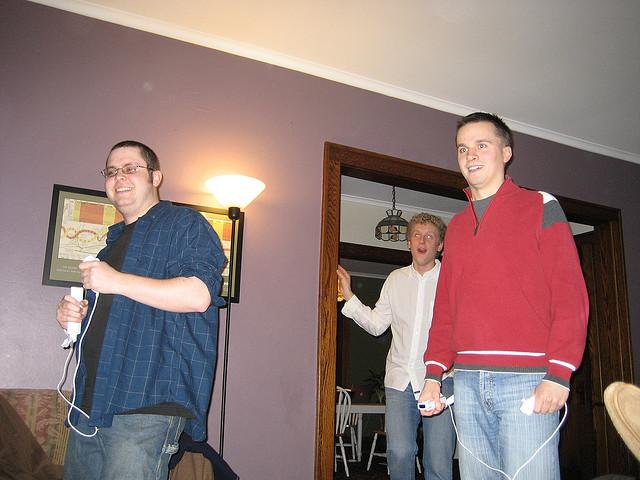What are they looking at? Please explain your reasoning. video screen. They are holding video game controllers and are all looking in the same direction. 